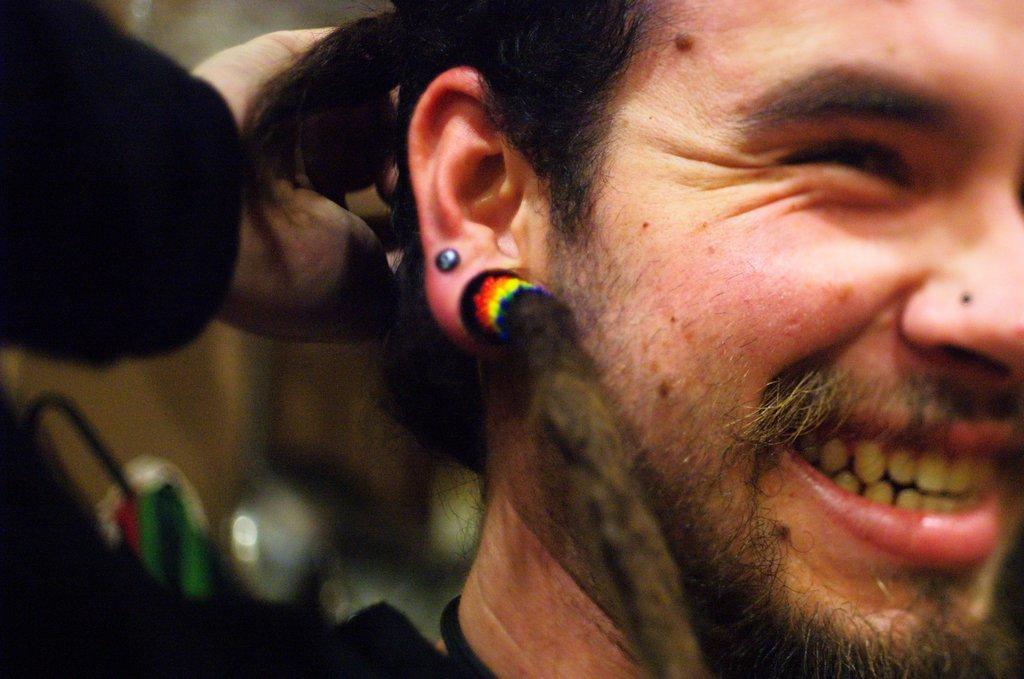Describe this image in one or two sentences. In this picture, we can see a person and the blurred background. 